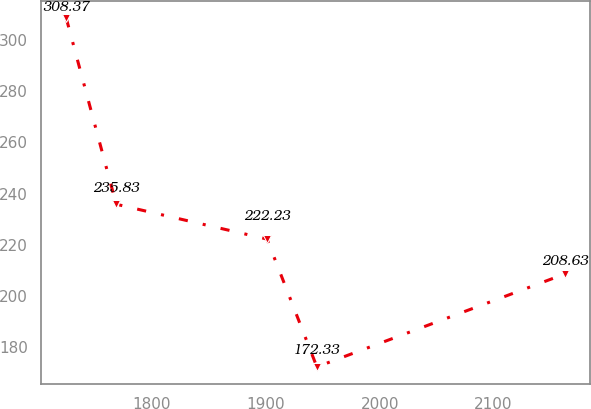Convert chart to OTSL. <chart><loc_0><loc_0><loc_500><loc_500><line_chart><ecel><fcel>Unnamed: 1<nl><fcel>1724.75<fcel>308.37<nl><fcel>1768.55<fcel>235.83<nl><fcel>1901<fcel>222.23<nl><fcel>1944.8<fcel>172.33<nl><fcel>2162.71<fcel>208.63<nl></chart> 